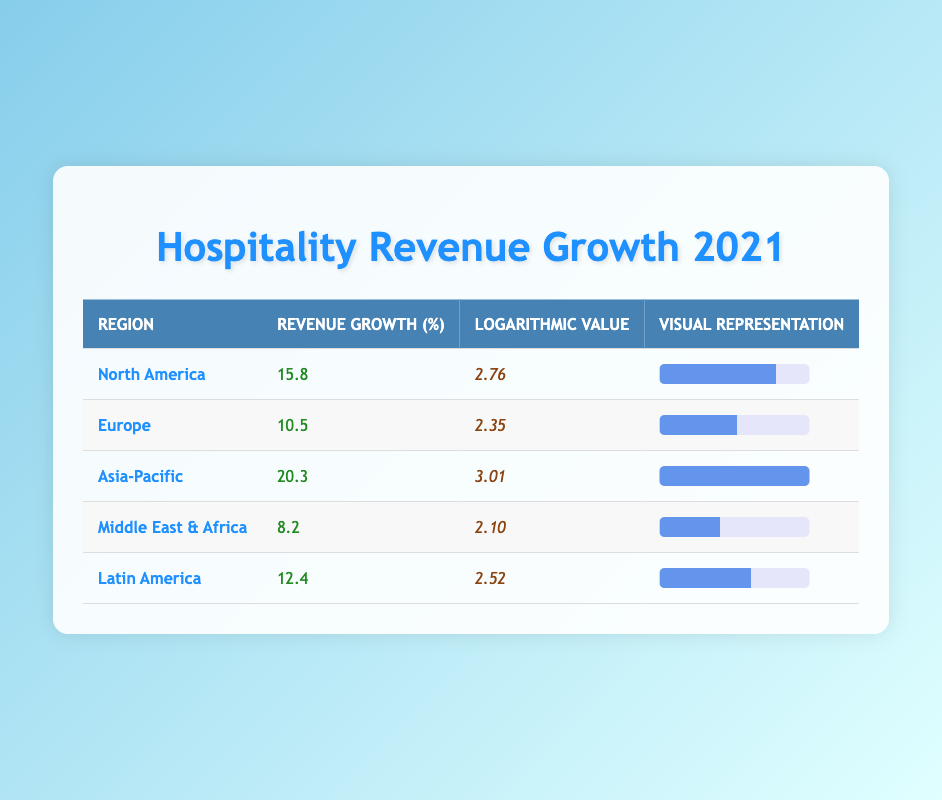What is the highest revenue growth percentage among the regions? The highest revenue growth percentage is found by comparing the values in the "Revenue Growth (%)" column. The values are 15.8, 10.5, 20.3, 8.2, and 12.4. Among these, 20.3 is the greatest.
Answer: 20.3 Which region has the lowest revenue growth? To find the lowest revenue growth, we look through the "Revenue Growth (%)" column and identify the smallest value. That value is 8.2 for the Middle East & Africa region.
Answer: 8.2 What is the logarithmic value for Europe? The logarithmic value for Europe is directly taken from the "Logarithmic Value" column, corresponding to Europe. The value listed is 2.35.
Answer: 2.35 Is the revenue growth in Asia-Pacific higher than in North America? To answer this, we compare the revenue growth percentages: Asia-Pacific has 20.3 and North America has 15.8. Since 20.3 is greater than 15.8, the statement is true.
Answer: Yes What is the average revenue growth across all regions? First, we add the revenue growth percentages: 15.8 + 10.5 + 20.3 + 8.2 + 12.4 = 67.2. Next, we divide by the number of regions, which is 5. So, 67.2 / 5 = 13.44.
Answer: 13.44 How many regions have revenue growth percentages greater than 12%? We will check each of the revenue growth percentage values: North America (15.8), Europe (10.5), Asia-Pacific (20.3), Middle East & Africa (8.2), and Latin America (12.4). North America, Asia-Pacific, and Latin America exceed 12%. Thus, there are 3 regions overall.
Answer: 3 Which region has a logarithmic value greater than 2.5? We review the "Logarithmic Value" column for values greater than 2.5. The logarithmic values are 2.76 (North America), 2.35 (Europe), 3.01 (Asia-Pacific), 2.10 (Middle East & Africa), and 2.52 (Latin America). The regions with values greater than 2.5 are North America, Asia-Pacific, and Latin America, indicating that 3 regions meet this criterion.
Answer: 3 Is the revenue growth in Latin America less than 13%? The revenue growth for Latin America is 12.4%. Since this is less than 13%, the answer is true.
Answer: Yes What percentage more is the revenue growth in Asia-Pacific than in Europe? We calculate the difference between Asia-Pacific's revenue growth (20.3) and Europe's (10.5): 20.3 - 10.5 = 9.8. Then, we find the percentage more: (9.8 / 10.5) * 100 = approximately 93.33%.
Answer: Approximately 93.33% 